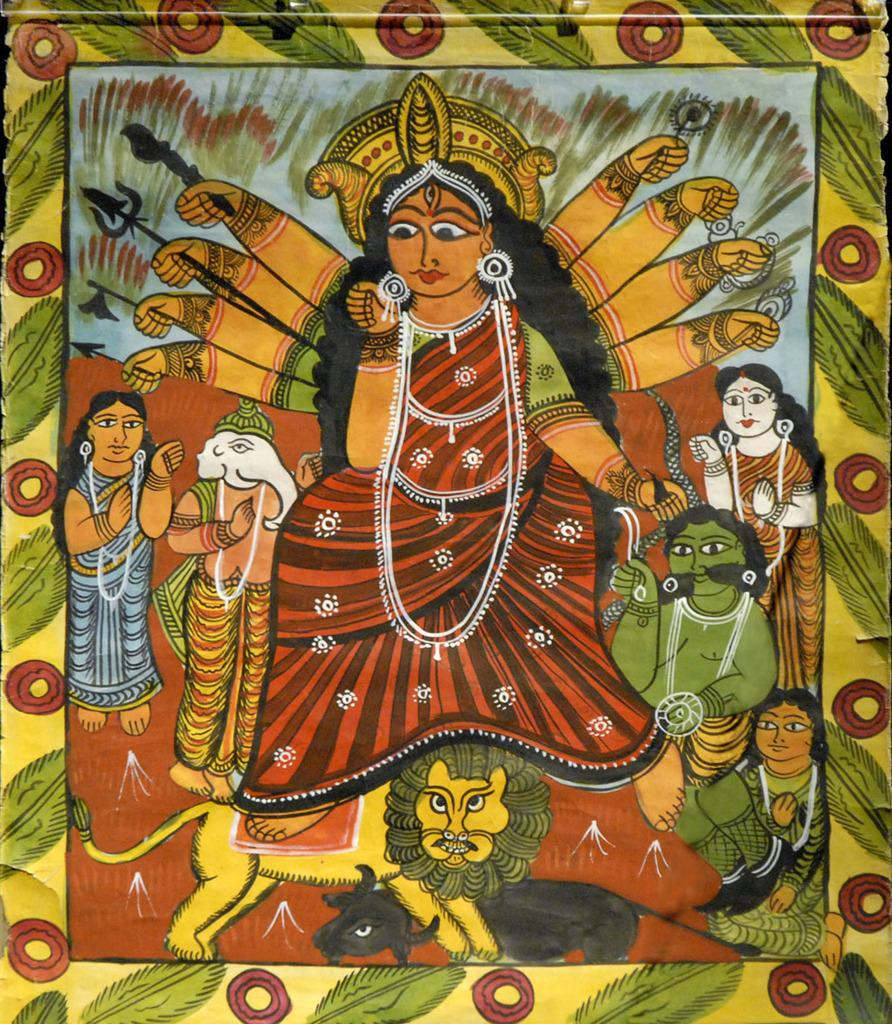What is the main subject in the center of the image? There is a frame in the center of the image. What is inside the frame? The frame contains a painting. What does the painting depict? The painting depicts a lord. Are there any other elements in the painting besides the lord? Yes, there are people, a lion, and a cow in the painting. How many cushions are on the boat in the image? There are no boats or cushions present in the image. What type of honey is being collected by the bees in the painting? There are no bees or honey mentioned in the image or the painting. 